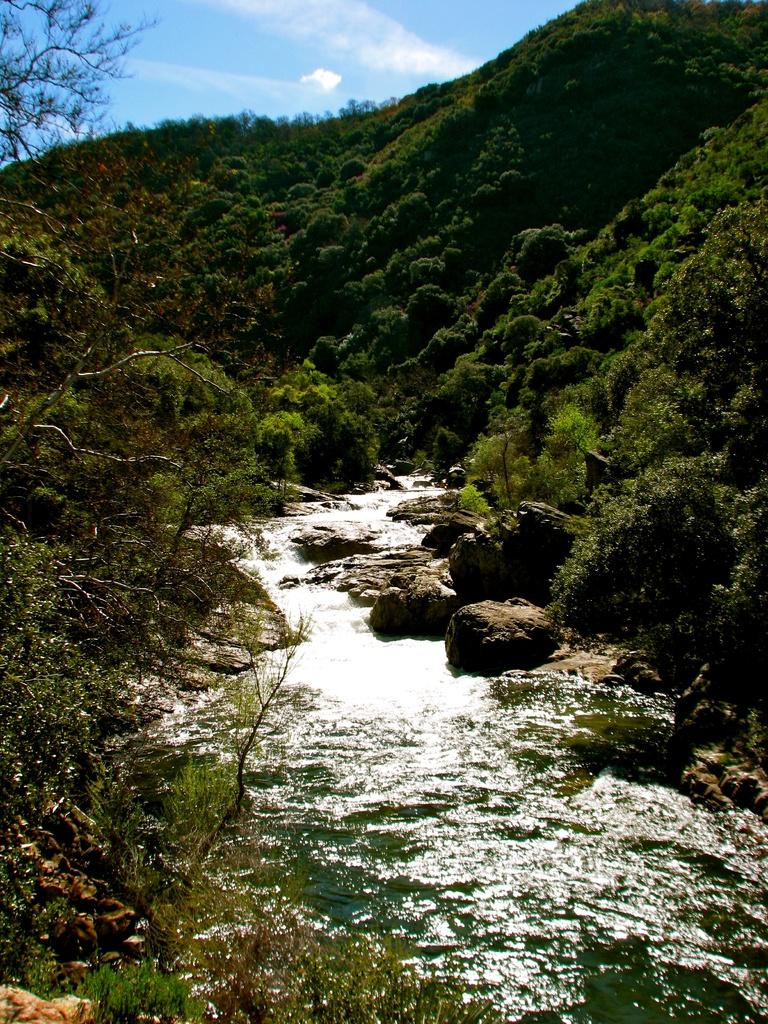What type of natural formation is visible in the image? There are mountains in the image. What can be seen on the mountains? There are trees and plants on the mountains. What is flowing in the center of the image? There is water flowing in the center of the image. What is located beside the water? There are rocks beside the water. What is visible at the top of the image? The sky is visible at the top of the image. Where is the cow grazing in the image? There is no cow present in the image. What type of power source can be seen in the image? There is no power source visible in the image. 